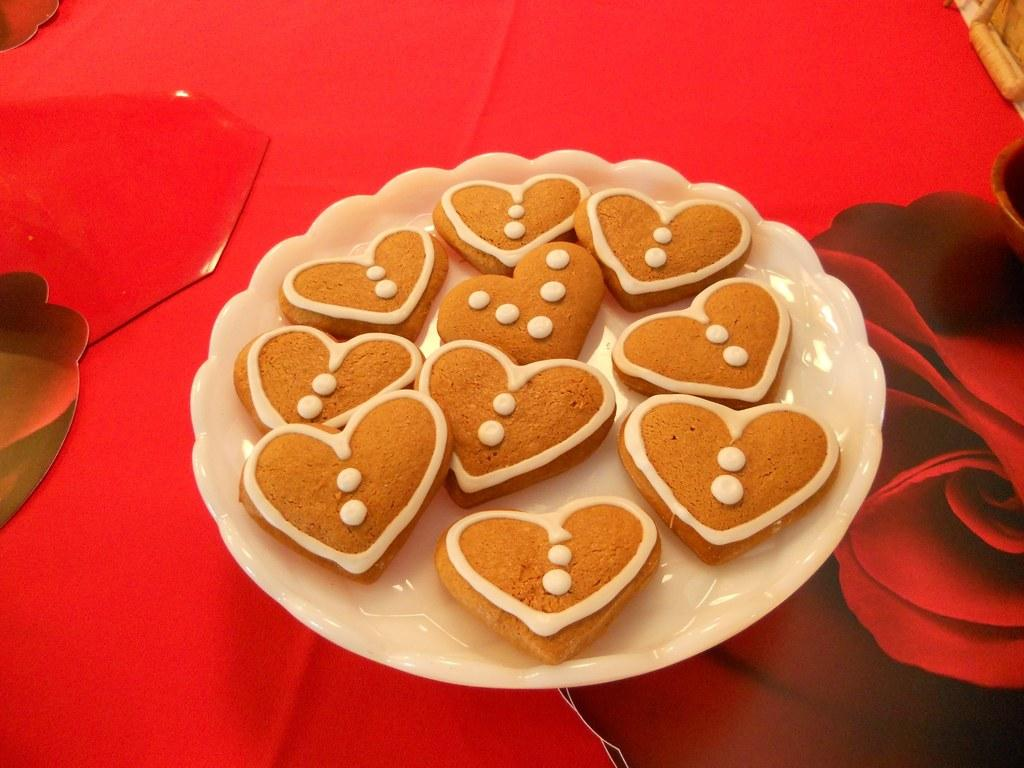What type of food can be seen in the image? There are cookies in the image. Where are the cookies located? The cookies are in a plate. How many eyes can be seen on the cookies in the image? There are no eyes visible on the cookies in the image, as cookies do not have eyes. 